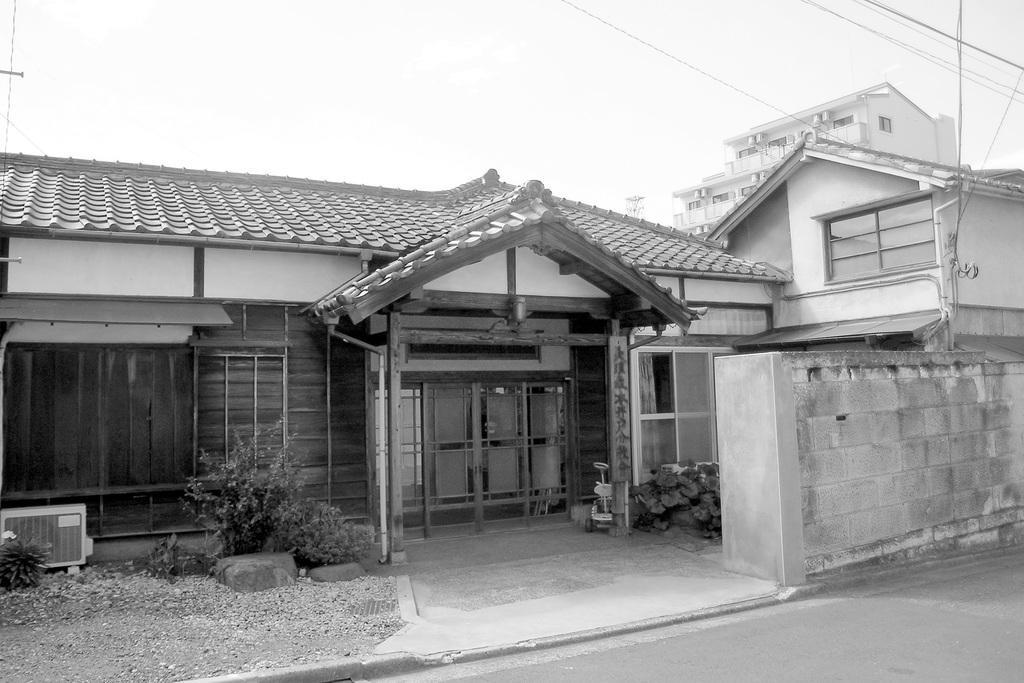In one or two sentences, can you explain what this image depicts? In this image there is a front view of the house,there is a plant, there is a road,there is a building,there are wires,there is a sky. 